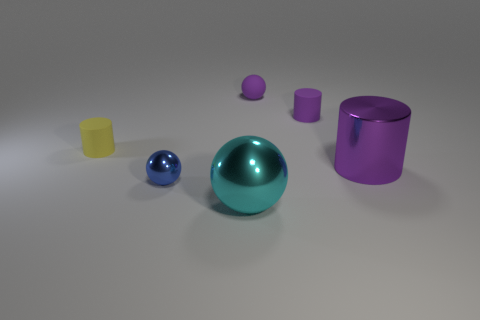Add 3 big purple metal cylinders. How many objects exist? 9 Add 6 tiny matte balls. How many tiny matte balls are left? 7 Add 5 big purple cylinders. How many big purple cylinders exist? 6 Subtract 0 blue cubes. How many objects are left? 6 Subtract all tiny cyan metallic balls. Subtract all purple objects. How many objects are left? 3 